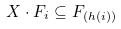Convert formula to latex. <formula><loc_0><loc_0><loc_500><loc_500>X \cdot F _ { i } \subseteq F _ { ( h ( i ) ) }</formula> 